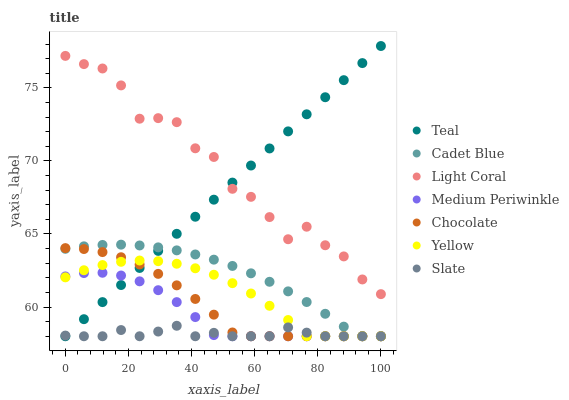Does Slate have the minimum area under the curve?
Answer yes or no. Yes. Does Light Coral have the maximum area under the curve?
Answer yes or no. Yes. Does Medium Periwinkle have the minimum area under the curve?
Answer yes or no. No. Does Medium Periwinkle have the maximum area under the curve?
Answer yes or no. No. Is Teal the smoothest?
Answer yes or no. Yes. Is Light Coral the roughest?
Answer yes or no. Yes. Is Slate the smoothest?
Answer yes or no. No. Is Slate the roughest?
Answer yes or no. No. Does Cadet Blue have the lowest value?
Answer yes or no. Yes. Does Light Coral have the lowest value?
Answer yes or no. No. Does Teal have the highest value?
Answer yes or no. Yes. Does Medium Periwinkle have the highest value?
Answer yes or no. No. Is Medium Periwinkle less than Light Coral?
Answer yes or no. Yes. Is Light Coral greater than Medium Periwinkle?
Answer yes or no. Yes. Does Slate intersect Cadet Blue?
Answer yes or no. Yes. Is Slate less than Cadet Blue?
Answer yes or no. No. Is Slate greater than Cadet Blue?
Answer yes or no. No. Does Medium Periwinkle intersect Light Coral?
Answer yes or no. No. 